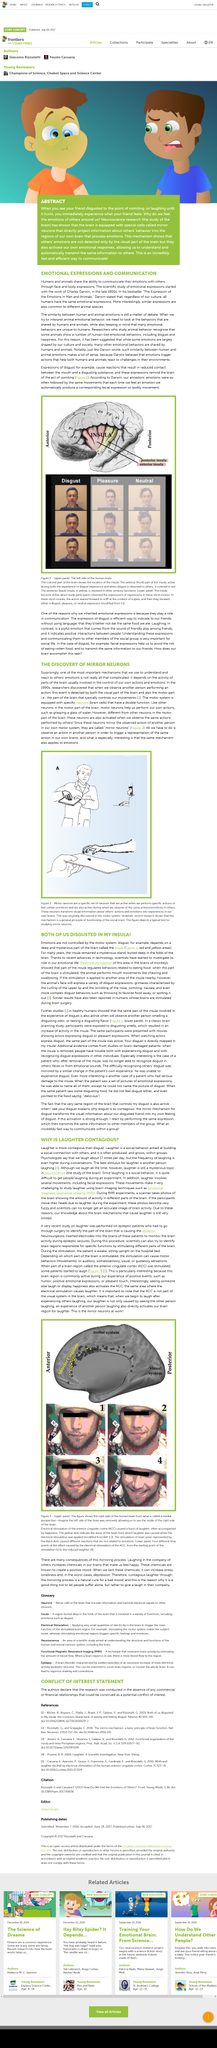Outline some significant characteristics in this image. The example being illustrated in the image is the scenario of your friend feeling disgusted to the point of vomiting, as described in the text. According to Charles Darwin, regardless of cultural differences, all humans have the same emotional expressions. The scientific study of emotional expressions began in the late 1800s, as documented by Charles Darwin. Charles Darwin's best-selling book is "The Expression of the Emotions in Man and Animals". Mirror neurons directly transmit information about others' behavior to the regions of our brain that process emotions. 